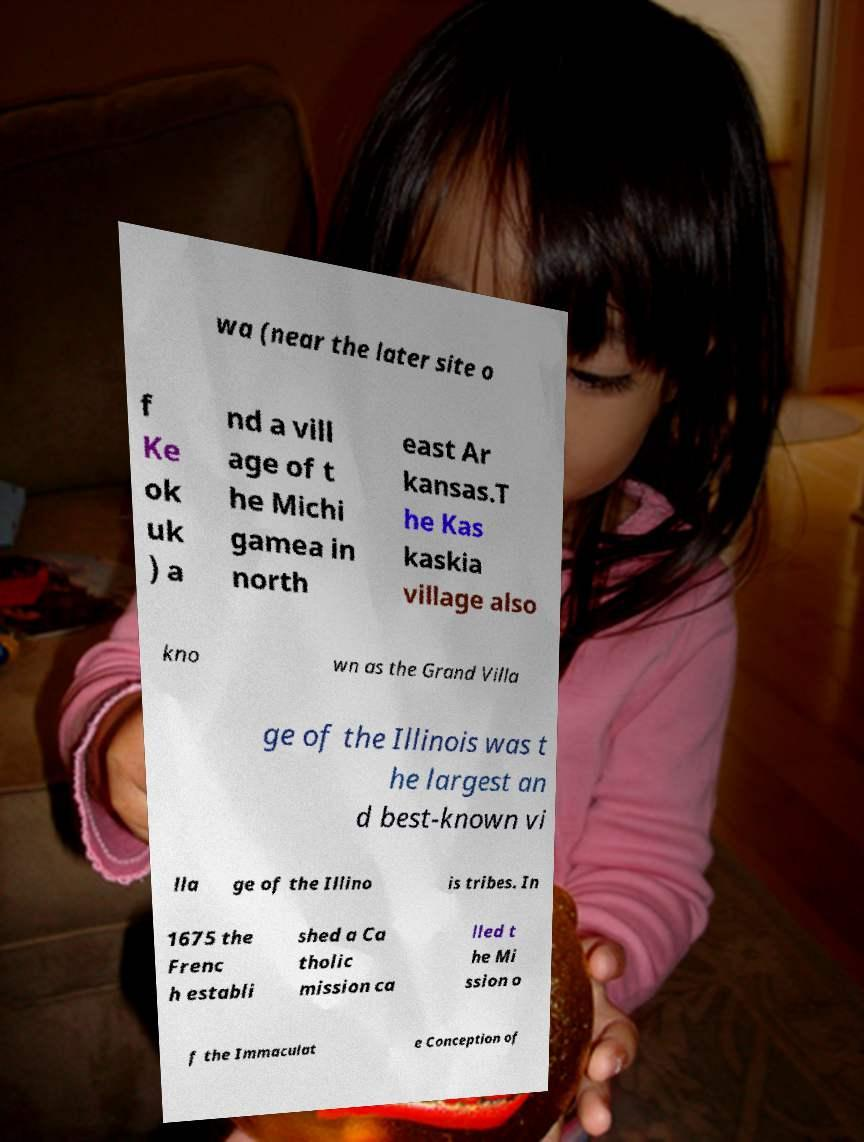Could you assist in decoding the text presented in this image and type it out clearly? wa (near the later site o f Ke ok uk ) a nd a vill age of t he Michi gamea in north east Ar kansas.T he Kas kaskia village also kno wn as the Grand Villa ge of the Illinois was t he largest an d best-known vi lla ge of the Illino is tribes. In 1675 the Frenc h establi shed a Ca tholic mission ca lled t he Mi ssion o f the Immaculat e Conception of 